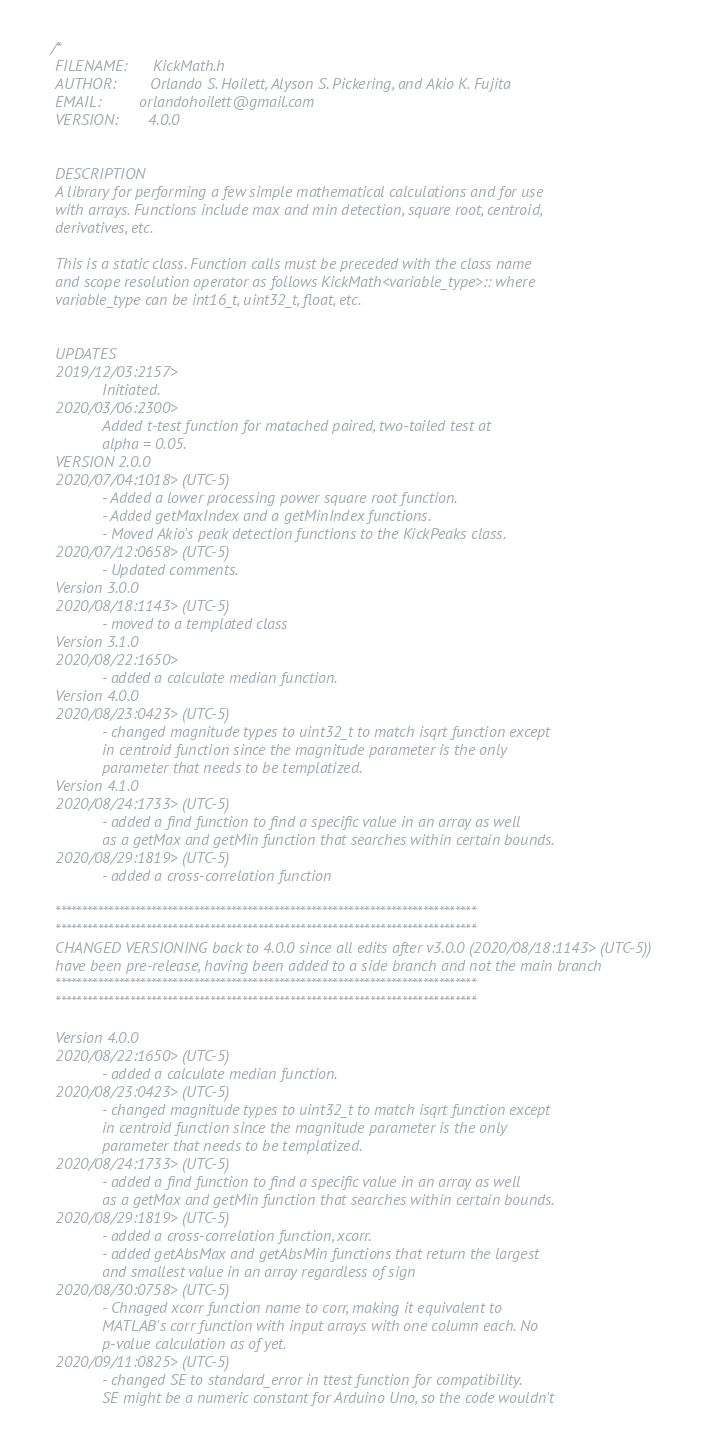Convert code to text. <code><loc_0><loc_0><loc_500><loc_500><_C_>/*
 FILENAME:      KickMath.h
 AUTHOR:        Orlando S. Hoilett, Alyson S. Pickering, and Akio K. Fujita
 EMAIL:     	orlandohoilett@gmail.com
 VERSION:		4.0.0
 
 
 DESCRIPTION
 A library for performing a few simple mathematical calculations and for use
 with arrays. Functions include max and min detection, square root, centroid,
 derivatives, etc.
 
 This is a static class. Function calls must be preceded with the class name
 and scope resolution operator as follows KickMath<variable_type>:: where
 variable_type can be int16_t, uint32_t, float, etc.
 
 
 UPDATES
 2019/12/03:2157>
 			Initiated.
 2020/03/06:2300>
 			Added t-test function for matached paired, two-tailed test at
 			alpha = 0.05.
 VERSION 2.0.0
 2020/07/04:1018> (UTC-5)
 			- Added a lower processing power square root function.
 			- Added getMaxIndex and a getMinIndex functions.
 			- Moved Akio's peak detection functions to the KickPeaks class.
 2020/07/12:0658> (UTC-5)
 			- Updated comments.
 Version 3.0.0
 2020/08/18:1143> (UTC-5)
 			- moved to a templated class
 Version 3.1.0
 2020/08/22:1650>
 			- added a calculate median function.
 Version 4.0.0
 2020/08/23:0423> (UTC-5)
 			- changed magnitude types to uint32_t to match isqrt function except
 			in centroid function since the magnitude parameter is the only
 			parameter that needs to be templatized.
 Version 4.1.0
 2020/08/24:1733> (UTC-5)
 			- added a find function to find a specific value in an array as well
			as a getMax and getMin function that searches within certain bounds.
 2020/08/29:1819> (UTC-5)
			- added a cross-correlation function
 
 *******************************************************************************
 *******************************************************************************
 CHANGED VERSIONING back to 4.0.0 since all edits after v3.0.0 (2020/08/18:1143> (UTC-5))
 have been pre-release, having been added to a side branch and not the main branch
 *******************************************************************************
 *******************************************************************************
 
 Version 4.0.0
 2020/08/22:1650> (UTC-5)
 			- added a calculate median function.
 2020/08/23:0423> (UTC-5)
 			- changed magnitude types to uint32_t to match isqrt function except
 			in centroid function since the magnitude parameter is the only
 			parameter that needs to be templatized.
 2020/08/24:1733> (UTC-5)
 			- added a find function to find a specific value in an array as well
 			as a getMax and getMin function that searches within certain bounds.
 2020/08/29:1819> (UTC-5)
 			- added a cross-correlation function, xcorr.
 			- added getAbsMax and getAbsMin functions that return the largest
 			and smallest value in an array regardless of sign
 2020/08/30:0758> (UTC-5)
 			- Chnaged xcorr function name to corr, making it equivalent to
 			MATLAB's corr function with input arrays with one column each. No
			p-value calculation as of yet.
 2020/09/11:0825> (UTC-5)
 			- changed SE to standard_error in ttest function for compatibility.
 			SE might be a numeric constant for Arduino Uno, so the code wouldn't</code> 